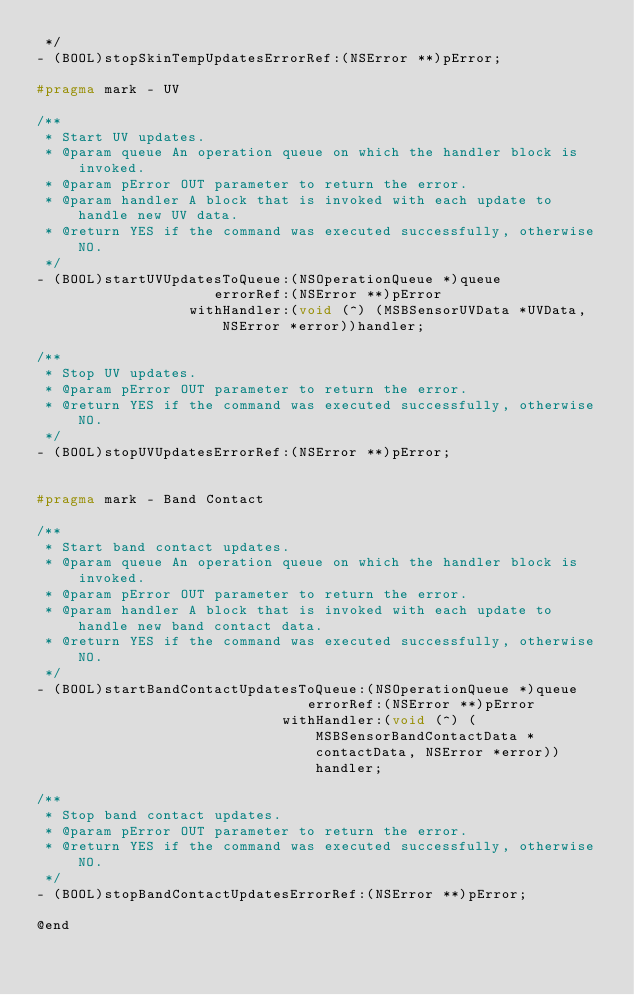<code> <loc_0><loc_0><loc_500><loc_500><_C_> */
- (BOOL)stopSkinTempUpdatesErrorRef:(NSError **)pError;

#pragma mark - UV

/**
 * Start UV updates.
 * @param queue An operation queue on which the handler block is invoked.
 * @param pError OUT parameter to return the error.
 * @param handler A block that is invoked with each update to handle new UV data.
 * @return YES if the command was executed successfully, otherwise NO.
 */
- (BOOL)startUVUpdatesToQueue:(NSOperationQueue *)queue
                     errorRef:(NSError **)pError
                  withHandler:(void (^) (MSBSensorUVData *UVData, NSError *error))handler;

/**
 * Stop UV updates.
 * @param pError OUT parameter to return the error.
 * @return YES if the command was executed successfully, otherwise NO.
 */
- (BOOL)stopUVUpdatesErrorRef:(NSError **)pError;


#pragma mark - Band Contact

/**
 * Start band contact updates.
 * @param queue An operation queue on which the handler block is invoked.
 * @param pError OUT parameter to return the error.
 * @param handler A block that is invoked with each update to handle new band contact data.
 * @return YES if the command was executed successfully, otherwise NO.
 */
- (BOOL)startBandContactUpdatesToQueue:(NSOperationQueue *)queue
                                errorRef:(NSError **)pError
                             withHandler:(void (^) (MSBSensorBandContactData *contactData, NSError *error))handler;

/**
 * Stop band contact updates.
 * @param pError OUT parameter to return the error.
 * @return YES if the command was executed successfully, otherwise NO.
 */
- (BOOL)stopBandContactUpdatesErrorRef:(NSError **)pError;

@end
</code> 